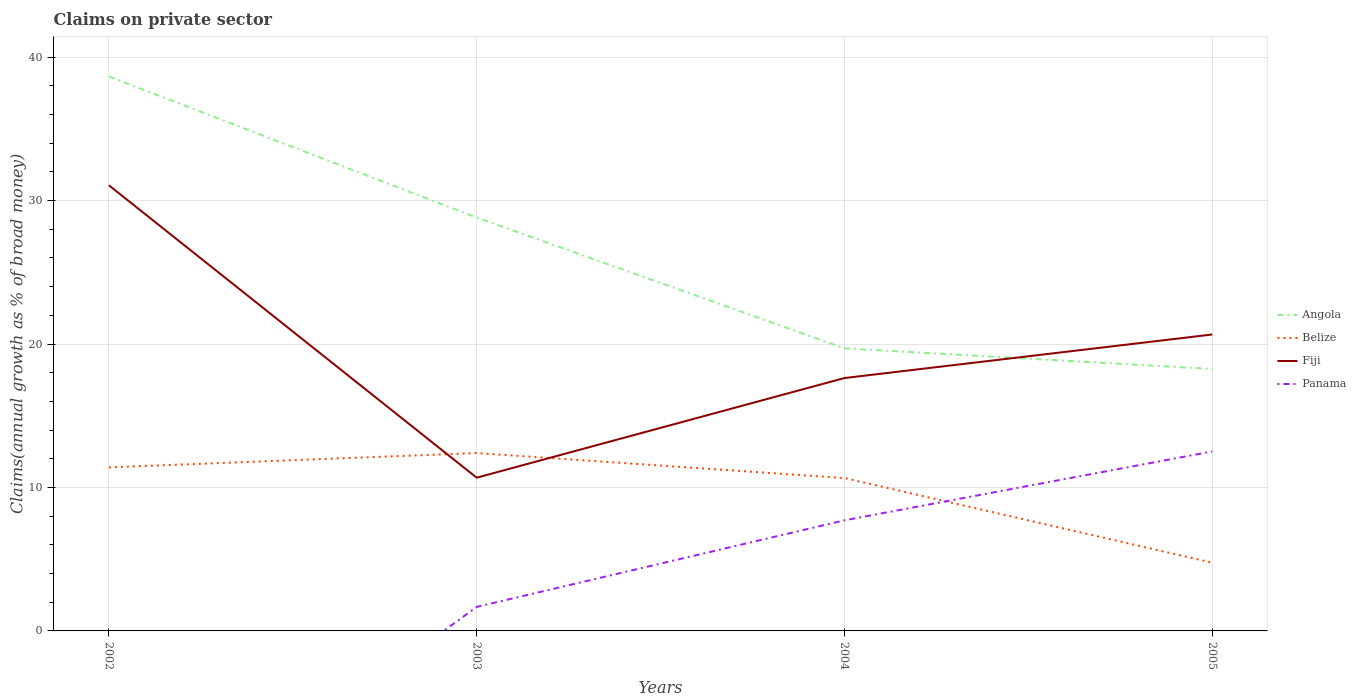What is the total percentage of broad money claimed on private sector in Belize in the graph?
Make the answer very short. 7.65. What is the difference between the highest and the second highest percentage of broad money claimed on private sector in Angola?
Keep it short and to the point. 20.39. How many lines are there?
Your response must be concise. 4. How many years are there in the graph?
Your response must be concise. 4. What is the difference between two consecutive major ticks on the Y-axis?
Ensure brevity in your answer.  10. Does the graph contain grids?
Offer a very short reply. Yes. How many legend labels are there?
Your answer should be compact. 4. What is the title of the graph?
Your response must be concise. Claims on private sector. What is the label or title of the X-axis?
Offer a terse response. Years. What is the label or title of the Y-axis?
Keep it short and to the point. Claims(annual growth as % of broad money). What is the Claims(annual growth as % of broad money) in Angola in 2002?
Provide a short and direct response. 38.65. What is the Claims(annual growth as % of broad money) of Belize in 2002?
Your response must be concise. 11.4. What is the Claims(annual growth as % of broad money) of Fiji in 2002?
Your answer should be very brief. 31.07. What is the Claims(annual growth as % of broad money) in Panama in 2002?
Your response must be concise. 0. What is the Claims(annual growth as % of broad money) of Angola in 2003?
Your answer should be compact. 28.82. What is the Claims(annual growth as % of broad money) in Belize in 2003?
Offer a terse response. 12.4. What is the Claims(annual growth as % of broad money) in Fiji in 2003?
Your answer should be very brief. 10.68. What is the Claims(annual growth as % of broad money) of Panama in 2003?
Make the answer very short. 1.67. What is the Claims(annual growth as % of broad money) in Angola in 2004?
Your answer should be very brief. 19.7. What is the Claims(annual growth as % of broad money) in Belize in 2004?
Ensure brevity in your answer.  10.66. What is the Claims(annual growth as % of broad money) of Fiji in 2004?
Your answer should be very brief. 17.63. What is the Claims(annual growth as % of broad money) of Panama in 2004?
Make the answer very short. 7.71. What is the Claims(annual growth as % of broad money) in Angola in 2005?
Offer a very short reply. 18.26. What is the Claims(annual growth as % of broad money) of Belize in 2005?
Your answer should be very brief. 4.76. What is the Claims(annual growth as % of broad money) of Fiji in 2005?
Your answer should be very brief. 20.67. What is the Claims(annual growth as % of broad money) in Panama in 2005?
Provide a short and direct response. 12.51. Across all years, what is the maximum Claims(annual growth as % of broad money) of Angola?
Your answer should be compact. 38.65. Across all years, what is the maximum Claims(annual growth as % of broad money) in Belize?
Make the answer very short. 12.4. Across all years, what is the maximum Claims(annual growth as % of broad money) of Fiji?
Provide a succinct answer. 31.07. Across all years, what is the maximum Claims(annual growth as % of broad money) of Panama?
Your response must be concise. 12.51. Across all years, what is the minimum Claims(annual growth as % of broad money) in Angola?
Offer a very short reply. 18.26. Across all years, what is the minimum Claims(annual growth as % of broad money) in Belize?
Your response must be concise. 4.76. Across all years, what is the minimum Claims(annual growth as % of broad money) of Fiji?
Your answer should be compact. 10.68. What is the total Claims(annual growth as % of broad money) of Angola in the graph?
Make the answer very short. 105.43. What is the total Claims(annual growth as % of broad money) of Belize in the graph?
Provide a short and direct response. 39.22. What is the total Claims(annual growth as % of broad money) in Fiji in the graph?
Ensure brevity in your answer.  80.05. What is the total Claims(annual growth as % of broad money) of Panama in the graph?
Your response must be concise. 21.9. What is the difference between the Claims(annual growth as % of broad money) of Angola in 2002 and that in 2003?
Give a very brief answer. 9.83. What is the difference between the Claims(annual growth as % of broad money) in Belize in 2002 and that in 2003?
Provide a succinct answer. -1. What is the difference between the Claims(annual growth as % of broad money) of Fiji in 2002 and that in 2003?
Your answer should be compact. 20.39. What is the difference between the Claims(annual growth as % of broad money) of Angola in 2002 and that in 2004?
Your answer should be very brief. 18.95. What is the difference between the Claims(annual growth as % of broad money) in Belize in 2002 and that in 2004?
Offer a very short reply. 0.75. What is the difference between the Claims(annual growth as % of broad money) of Fiji in 2002 and that in 2004?
Offer a terse response. 13.44. What is the difference between the Claims(annual growth as % of broad money) in Angola in 2002 and that in 2005?
Provide a succinct answer. 20.39. What is the difference between the Claims(annual growth as % of broad money) in Belize in 2002 and that in 2005?
Provide a succinct answer. 6.65. What is the difference between the Claims(annual growth as % of broad money) in Fiji in 2002 and that in 2005?
Offer a terse response. 10.4. What is the difference between the Claims(annual growth as % of broad money) in Angola in 2003 and that in 2004?
Your answer should be very brief. 9.12. What is the difference between the Claims(annual growth as % of broad money) in Belize in 2003 and that in 2004?
Ensure brevity in your answer.  1.75. What is the difference between the Claims(annual growth as % of broad money) in Fiji in 2003 and that in 2004?
Provide a short and direct response. -6.95. What is the difference between the Claims(annual growth as % of broad money) of Panama in 2003 and that in 2004?
Give a very brief answer. -6.04. What is the difference between the Claims(annual growth as % of broad money) in Angola in 2003 and that in 2005?
Your answer should be compact. 10.56. What is the difference between the Claims(annual growth as % of broad money) of Belize in 2003 and that in 2005?
Keep it short and to the point. 7.65. What is the difference between the Claims(annual growth as % of broad money) in Fiji in 2003 and that in 2005?
Offer a terse response. -9.98. What is the difference between the Claims(annual growth as % of broad money) in Panama in 2003 and that in 2005?
Offer a terse response. -10.84. What is the difference between the Claims(annual growth as % of broad money) in Angola in 2004 and that in 2005?
Keep it short and to the point. 1.44. What is the difference between the Claims(annual growth as % of broad money) of Belize in 2004 and that in 2005?
Give a very brief answer. 5.9. What is the difference between the Claims(annual growth as % of broad money) of Fiji in 2004 and that in 2005?
Your answer should be compact. -3.04. What is the difference between the Claims(annual growth as % of broad money) in Angola in 2002 and the Claims(annual growth as % of broad money) in Belize in 2003?
Make the answer very short. 26.25. What is the difference between the Claims(annual growth as % of broad money) in Angola in 2002 and the Claims(annual growth as % of broad money) in Fiji in 2003?
Provide a succinct answer. 27.97. What is the difference between the Claims(annual growth as % of broad money) of Angola in 2002 and the Claims(annual growth as % of broad money) of Panama in 2003?
Provide a short and direct response. 36.98. What is the difference between the Claims(annual growth as % of broad money) of Belize in 2002 and the Claims(annual growth as % of broad money) of Fiji in 2003?
Offer a very short reply. 0.72. What is the difference between the Claims(annual growth as % of broad money) of Belize in 2002 and the Claims(annual growth as % of broad money) of Panama in 2003?
Keep it short and to the point. 9.73. What is the difference between the Claims(annual growth as % of broad money) of Fiji in 2002 and the Claims(annual growth as % of broad money) of Panama in 2003?
Your response must be concise. 29.39. What is the difference between the Claims(annual growth as % of broad money) in Angola in 2002 and the Claims(annual growth as % of broad money) in Belize in 2004?
Ensure brevity in your answer.  28. What is the difference between the Claims(annual growth as % of broad money) of Angola in 2002 and the Claims(annual growth as % of broad money) of Fiji in 2004?
Make the answer very short. 21.02. What is the difference between the Claims(annual growth as % of broad money) of Angola in 2002 and the Claims(annual growth as % of broad money) of Panama in 2004?
Ensure brevity in your answer.  30.94. What is the difference between the Claims(annual growth as % of broad money) in Belize in 2002 and the Claims(annual growth as % of broad money) in Fiji in 2004?
Keep it short and to the point. -6.23. What is the difference between the Claims(annual growth as % of broad money) of Belize in 2002 and the Claims(annual growth as % of broad money) of Panama in 2004?
Offer a very short reply. 3.69. What is the difference between the Claims(annual growth as % of broad money) of Fiji in 2002 and the Claims(annual growth as % of broad money) of Panama in 2004?
Offer a very short reply. 23.36. What is the difference between the Claims(annual growth as % of broad money) of Angola in 2002 and the Claims(annual growth as % of broad money) of Belize in 2005?
Provide a short and direct response. 33.9. What is the difference between the Claims(annual growth as % of broad money) in Angola in 2002 and the Claims(annual growth as % of broad money) in Fiji in 2005?
Keep it short and to the point. 17.99. What is the difference between the Claims(annual growth as % of broad money) in Angola in 2002 and the Claims(annual growth as % of broad money) in Panama in 2005?
Your answer should be very brief. 26.14. What is the difference between the Claims(annual growth as % of broad money) in Belize in 2002 and the Claims(annual growth as % of broad money) in Fiji in 2005?
Provide a succinct answer. -9.26. What is the difference between the Claims(annual growth as % of broad money) of Belize in 2002 and the Claims(annual growth as % of broad money) of Panama in 2005?
Keep it short and to the point. -1.11. What is the difference between the Claims(annual growth as % of broad money) of Fiji in 2002 and the Claims(annual growth as % of broad money) of Panama in 2005?
Give a very brief answer. 18.56. What is the difference between the Claims(annual growth as % of broad money) in Angola in 2003 and the Claims(annual growth as % of broad money) in Belize in 2004?
Provide a short and direct response. 18.16. What is the difference between the Claims(annual growth as % of broad money) in Angola in 2003 and the Claims(annual growth as % of broad money) in Fiji in 2004?
Your answer should be compact. 11.19. What is the difference between the Claims(annual growth as % of broad money) in Angola in 2003 and the Claims(annual growth as % of broad money) in Panama in 2004?
Ensure brevity in your answer.  21.11. What is the difference between the Claims(annual growth as % of broad money) of Belize in 2003 and the Claims(annual growth as % of broad money) of Fiji in 2004?
Offer a very short reply. -5.23. What is the difference between the Claims(annual growth as % of broad money) in Belize in 2003 and the Claims(annual growth as % of broad money) in Panama in 2004?
Your answer should be compact. 4.69. What is the difference between the Claims(annual growth as % of broad money) of Fiji in 2003 and the Claims(annual growth as % of broad money) of Panama in 2004?
Ensure brevity in your answer.  2.97. What is the difference between the Claims(annual growth as % of broad money) in Angola in 2003 and the Claims(annual growth as % of broad money) in Belize in 2005?
Provide a succinct answer. 24.06. What is the difference between the Claims(annual growth as % of broad money) of Angola in 2003 and the Claims(annual growth as % of broad money) of Fiji in 2005?
Give a very brief answer. 8.15. What is the difference between the Claims(annual growth as % of broad money) in Angola in 2003 and the Claims(annual growth as % of broad money) in Panama in 2005?
Provide a short and direct response. 16.31. What is the difference between the Claims(annual growth as % of broad money) of Belize in 2003 and the Claims(annual growth as % of broad money) of Fiji in 2005?
Give a very brief answer. -8.26. What is the difference between the Claims(annual growth as % of broad money) of Belize in 2003 and the Claims(annual growth as % of broad money) of Panama in 2005?
Your answer should be very brief. -0.11. What is the difference between the Claims(annual growth as % of broad money) in Fiji in 2003 and the Claims(annual growth as % of broad money) in Panama in 2005?
Ensure brevity in your answer.  -1.83. What is the difference between the Claims(annual growth as % of broad money) in Angola in 2004 and the Claims(annual growth as % of broad money) in Belize in 2005?
Offer a very short reply. 14.94. What is the difference between the Claims(annual growth as % of broad money) in Angola in 2004 and the Claims(annual growth as % of broad money) in Fiji in 2005?
Give a very brief answer. -0.97. What is the difference between the Claims(annual growth as % of broad money) of Angola in 2004 and the Claims(annual growth as % of broad money) of Panama in 2005?
Your answer should be compact. 7.19. What is the difference between the Claims(annual growth as % of broad money) in Belize in 2004 and the Claims(annual growth as % of broad money) in Fiji in 2005?
Provide a succinct answer. -10.01. What is the difference between the Claims(annual growth as % of broad money) of Belize in 2004 and the Claims(annual growth as % of broad money) of Panama in 2005?
Provide a succinct answer. -1.86. What is the difference between the Claims(annual growth as % of broad money) of Fiji in 2004 and the Claims(annual growth as % of broad money) of Panama in 2005?
Give a very brief answer. 5.12. What is the average Claims(annual growth as % of broad money) of Angola per year?
Provide a short and direct response. 26.36. What is the average Claims(annual growth as % of broad money) of Belize per year?
Ensure brevity in your answer.  9.8. What is the average Claims(annual growth as % of broad money) of Fiji per year?
Your response must be concise. 20.01. What is the average Claims(annual growth as % of broad money) in Panama per year?
Your response must be concise. 5.47. In the year 2002, what is the difference between the Claims(annual growth as % of broad money) of Angola and Claims(annual growth as % of broad money) of Belize?
Give a very brief answer. 27.25. In the year 2002, what is the difference between the Claims(annual growth as % of broad money) in Angola and Claims(annual growth as % of broad money) in Fiji?
Your answer should be very brief. 7.58. In the year 2002, what is the difference between the Claims(annual growth as % of broad money) in Belize and Claims(annual growth as % of broad money) in Fiji?
Keep it short and to the point. -19.67. In the year 2003, what is the difference between the Claims(annual growth as % of broad money) in Angola and Claims(annual growth as % of broad money) in Belize?
Make the answer very short. 16.42. In the year 2003, what is the difference between the Claims(annual growth as % of broad money) of Angola and Claims(annual growth as % of broad money) of Fiji?
Give a very brief answer. 18.13. In the year 2003, what is the difference between the Claims(annual growth as % of broad money) in Angola and Claims(annual growth as % of broad money) in Panama?
Offer a terse response. 27.14. In the year 2003, what is the difference between the Claims(annual growth as % of broad money) in Belize and Claims(annual growth as % of broad money) in Fiji?
Offer a very short reply. 1.72. In the year 2003, what is the difference between the Claims(annual growth as % of broad money) of Belize and Claims(annual growth as % of broad money) of Panama?
Your answer should be very brief. 10.73. In the year 2003, what is the difference between the Claims(annual growth as % of broad money) in Fiji and Claims(annual growth as % of broad money) in Panama?
Offer a very short reply. 9.01. In the year 2004, what is the difference between the Claims(annual growth as % of broad money) of Angola and Claims(annual growth as % of broad money) of Belize?
Offer a terse response. 9.04. In the year 2004, what is the difference between the Claims(annual growth as % of broad money) in Angola and Claims(annual growth as % of broad money) in Fiji?
Keep it short and to the point. 2.07. In the year 2004, what is the difference between the Claims(annual growth as % of broad money) in Angola and Claims(annual growth as % of broad money) in Panama?
Keep it short and to the point. 11.99. In the year 2004, what is the difference between the Claims(annual growth as % of broad money) in Belize and Claims(annual growth as % of broad money) in Fiji?
Offer a terse response. -6.97. In the year 2004, what is the difference between the Claims(annual growth as % of broad money) in Belize and Claims(annual growth as % of broad money) in Panama?
Keep it short and to the point. 2.94. In the year 2004, what is the difference between the Claims(annual growth as % of broad money) of Fiji and Claims(annual growth as % of broad money) of Panama?
Make the answer very short. 9.92. In the year 2005, what is the difference between the Claims(annual growth as % of broad money) in Angola and Claims(annual growth as % of broad money) in Belize?
Give a very brief answer. 13.5. In the year 2005, what is the difference between the Claims(annual growth as % of broad money) in Angola and Claims(annual growth as % of broad money) in Fiji?
Your answer should be very brief. -2.41. In the year 2005, what is the difference between the Claims(annual growth as % of broad money) of Angola and Claims(annual growth as % of broad money) of Panama?
Give a very brief answer. 5.75. In the year 2005, what is the difference between the Claims(annual growth as % of broad money) in Belize and Claims(annual growth as % of broad money) in Fiji?
Offer a very short reply. -15.91. In the year 2005, what is the difference between the Claims(annual growth as % of broad money) in Belize and Claims(annual growth as % of broad money) in Panama?
Offer a very short reply. -7.76. In the year 2005, what is the difference between the Claims(annual growth as % of broad money) of Fiji and Claims(annual growth as % of broad money) of Panama?
Give a very brief answer. 8.15. What is the ratio of the Claims(annual growth as % of broad money) of Angola in 2002 to that in 2003?
Provide a succinct answer. 1.34. What is the ratio of the Claims(annual growth as % of broad money) of Belize in 2002 to that in 2003?
Ensure brevity in your answer.  0.92. What is the ratio of the Claims(annual growth as % of broad money) in Fiji in 2002 to that in 2003?
Ensure brevity in your answer.  2.91. What is the ratio of the Claims(annual growth as % of broad money) of Angola in 2002 to that in 2004?
Offer a very short reply. 1.96. What is the ratio of the Claims(annual growth as % of broad money) in Belize in 2002 to that in 2004?
Your answer should be very brief. 1.07. What is the ratio of the Claims(annual growth as % of broad money) of Fiji in 2002 to that in 2004?
Your answer should be compact. 1.76. What is the ratio of the Claims(annual growth as % of broad money) of Angola in 2002 to that in 2005?
Your answer should be compact. 2.12. What is the ratio of the Claims(annual growth as % of broad money) in Belize in 2002 to that in 2005?
Your answer should be very brief. 2.4. What is the ratio of the Claims(annual growth as % of broad money) of Fiji in 2002 to that in 2005?
Keep it short and to the point. 1.5. What is the ratio of the Claims(annual growth as % of broad money) in Angola in 2003 to that in 2004?
Make the answer very short. 1.46. What is the ratio of the Claims(annual growth as % of broad money) of Belize in 2003 to that in 2004?
Offer a very short reply. 1.16. What is the ratio of the Claims(annual growth as % of broad money) of Fiji in 2003 to that in 2004?
Provide a succinct answer. 0.61. What is the ratio of the Claims(annual growth as % of broad money) of Panama in 2003 to that in 2004?
Ensure brevity in your answer.  0.22. What is the ratio of the Claims(annual growth as % of broad money) in Angola in 2003 to that in 2005?
Your answer should be very brief. 1.58. What is the ratio of the Claims(annual growth as % of broad money) in Belize in 2003 to that in 2005?
Offer a terse response. 2.61. What is the ratio of the Claims(annual growth as % of broad money) in Fiji in 2003 to that in 2005?
Ensure brevity in your answer.  0.52. What is the ratio of the Claims(annual growth as % of broad money) of Panama in 2003 to that in 2005?
Make the answer very short. 0.13. What is the ratio of the Claims(annual growth as % of broad money) of Angola in 2004 to that in 2005?
Provide a short and direct response. 1.08. What is the ratio of the Claims(annual growth as % of broad money) of Belize in 2004 to that in 2005?
Offer a very short reply. 2.24. What is the ratio of the Claims(annual growth as % of broad money) of Fiji in 2004 to that in 2005?
Offer a terse response. 0.85. What is the ratio of the Claims(annual growth as % of broad money) of Panama in 2004 to that in 2005?
Give a very brief answer. 0.62. What is the difference between the highest and the second highest Claims(annual growth as % of broad money) in Angola?
Offer a very short reply. 9.83. What is the difference between the highest and the second highest Claims(annual growth as % of broad money) in Fiji?
Provide a succinct answer. 10.4. What is the difference between the highest and the lowest Claims(annual growth as % of broad money) of Angola?
Your answer should be compact. 20.39. What is the difference between the highest and the lowest Claims(annual growth as % of broad money) in Belize?
Make the answer very short. 7.65. What is the difference between the highest and the lowest Claims(annual growth as % of broad money) of Fiji?
Give a very brief answer. 20.39. What is the difference between the highest and the lowest Claims(annual growth as % of broad money) of Panama?
Provide a succinct answer. 12.51. 